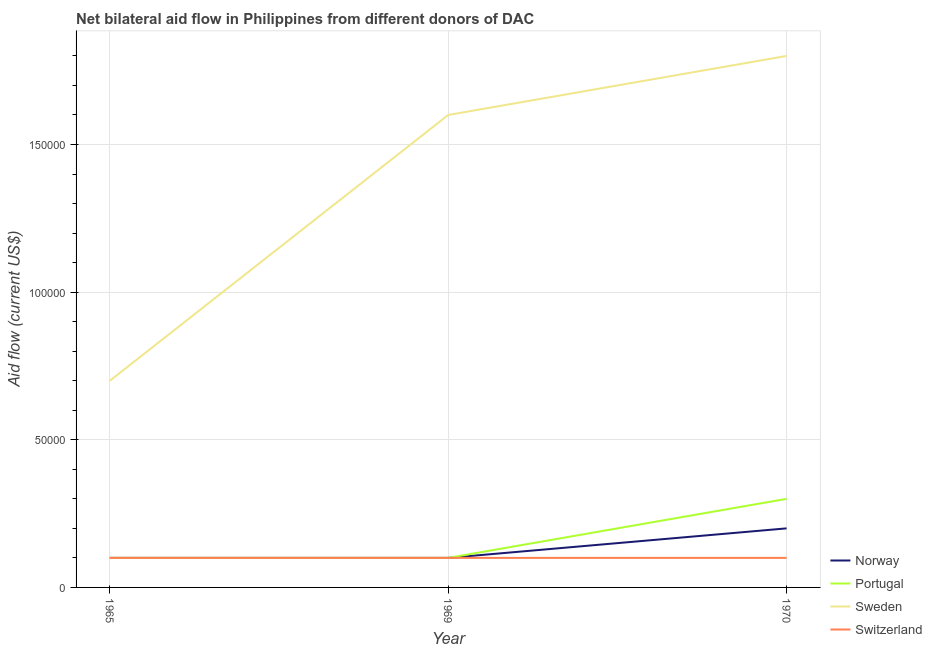How many different coloured lines are there?
Keep it short and to the point. 4. Does the line corresponding to amount of aid given by sweden intersect with the line corresponding to amount of aid given by portugal?
Provide a succinct answer. No. Is the number of lines equal to the number of legend labels?
Your response must be concise. Yes. What is the amount of aid given by switzerland in 1965?
Offer a terse response. 10000. Across all years, what is the maximum amount of aid given by sweden?
Provide a succinct answer. 1.80e+05. Across all years, what is the minimum amount of aid given by norway?
Offer a terse response. 10000. In which year was the amount of aid given by portugal maximum?
Your response must be concise. 1970. In which year was the amount of aid given by sweden minimum?
Provide a short and direct response. 1965. What is the total amount of aid given by norway in the graph?
Offer a very short reply. 4.00e+04. What is the difference between the amount of aid given by portugal in 1965 and that in 1970?
Provide a short and direct response. -2.00e+04. What is the difference between the amount of aid given by portugal in 1969 and the amount of aid given by switzerland in 1970?
Ensure brevity in your answer.  0. What is the average amount of aid given by switzerland per year?
Offer a terse response. 10000. In the year 1969, what is the difference between the amount of aid given by sweden and amount of aid given by switzerland?
Give a very brief answer. 1.50e+05. In how many years, is the amount of aid given by sweden greater than 10000 US$?
Make the answer very short. 3. What is the ratio of the amount of aid given by norway in 1965 to that in 1970?
Keep it short and to the point. 0.5. Is the difference between the amount of aid given by norway in 1969 and 1970 greater than the difference between the amount of aid given by portugal in 1969 and 1970?
Provide a succinct answer. Yes. What is the difference between the highest and the second highest amount of aid given by norway?
Your response must be concise. 10000. What is the difference between the highest and the lowest amount of aid given by norway?
Keep it short and to the point. 10000. Is it the case that in every year, the sum of the amount of aid given by norway and amount of aid given by portugal is greater than the amount of aid given by sweden?
Give a very brief answer. No. Is the amount of aid given by sweden strictly less than the amount of aid given by portugal over the years?
Keep it short and to the point. No. How many lines are there?
Give a very brief answer. 4. What is the difference between two consecutive major ticks on the Y-axis?
Keep it short and to the point. 5.00e+04. Are the values on the major ticks of Y-axis written in scientific E-notation?
Your response must be concise. No. Does the graph contain any zero values?
Your answer should be very brief. No. Does the graph contain grids?
Make the answer very short. Yes. How many legend labels are there?
Offer a terse response. 4. What is the title of the graph?
Ensure brevity in your answer.  Net bilateral aid flow in Philippines from different donors of DAC. What is the label or title of the X-axis?
Your response must be concise. Year. What is the label or title of the Y-axis?
Provide a short and direct response. Aid flow (current US$). What is the Aid flow (current US$) of Norway in 1965?
Provide a short and direct response. 10000. What is the Aid flow (current US$) of Sweden in 1969?
Your answer should be very brief. 1.60e+05. What is the Aid flow (current US$) of Norway in 1970?
Ensure brevity in your answer.  2.00e+04. What is the Aid flow (current US$) in Sweden in 1970?
Your answer should be compact. 1.80e+05. What is the Aid flow (current US$) of Switzerland in 1970?
Give a very brief answer. 10000. Across all years, what is the maximum Aid flow (current US$) of Norway?
Offer a terse response. 2.00e+04. Across all years, what is the maximum Aid flow (current US$) of Sweden?
Offer a very short reply. 1.80e+05. Across all years, what is the maximum Aid flow (current US$) of Switzerland?
Keep it short and to the point. 10000. Across all years, what is the minimum Aid flow (current US$) of Norway?
Your answer should be compact. 10000. Across all years, what is the minimum Aid flow (current US$) of Portugal?
Offer a very short reply. 10000. Across all years, what is the minimum Aid flow (current US$) in Sweden?
Make the answer very short. 7.00e+04. Across all years, what is the minimum Aid flow (current US$) in Switzerland?
Ensure brevity in your answer.  10000. What is the total Aid flow (current US$) in Norway in the graph?
Your answer should be compact. 4.00e+04. What is the total Aid flow (current US$) in Sweden in the graph?
Provide a short and direct response. 4.10e+05. What is the total Aid flow (current US$) in Switzerland in the graph?
Keep it short and to the point. 3.00e+04. What is the difference between the Aid flow (current US$) of Sweden in 1965 and that in 1969?
Make the answer very short. -9.00e+04. What is the difference between the Aid flow (current US$) in Switzerland in 1965 and that in 1969?
Ensure brevity in your answer.  0. What is the difference between the Aid flow (current US$) in Portugal in 1965 and that in 1970?
Provide a succinct answer. -2.00e+04. What is the difference between the Aid flow (current US$) in Switzerland in 1965 and that in 1970?
Make the answer very short. 0. What is the difference between the Aid flow (current US$) in Portugal in 1969 and that in 1970?
Your answer should be very brief. -2.00e+04. What is the difference between the Aid flow (current US$) in Sweden in 1969 and that in 1970?
Offer a very short reply. -2.00e+04. What is the difference between the Aid flow (current US$) of Switzerland in 1969 and that in 1970?
Give a very brief answer. 0. What is the difference between the Aid flow (current US$) of Norway in 1965 and the Aid flow (current US$) of Portugal in 1969?
Your answer should be compact. 0. What is the difference between the Aid flow (current US$) of Norway in 1965 and the Aid flow (current US$) of Switzerland in 1969?
Your response must be concise. 0. What is the difference between the Aid flow (current US$) in Portugal in 1965 and the Aid flow (current US$) in Sweden in 1969?
Your answer should be compact. -1.50e+05. What is the difference between the Aid flow (current US$) in Portugal in 1965 and the Aid flow (current US$) in Switzerland in 1969?
Make the answer very short. 0. What is the difference between the Aid flow (current US$) in Sweden in 1965 and the Aid flow (current US$) in Switzerland in 1969?
Offer a terse response. 6.00e+04. What is the difference between the Aid flow (current US$) of Norway in 1965 and the Aid flow (current US$) of Switzerland in 1970?
Your answer should be very brief. 0. What is the difference between the Aid flow (current US$) in Portugal in 1965 and the Aid flow (current US$) in Sweden in 1970?
Provide a succinct answer. -1.70e+05. What is the difference between the Aid flow (current US$) of Sweden in 1965 and the Aid flow (current US$) of Switzerland in 1970?
Offer a very short reply. 6.00e+04. What is the difference between the Aid flow (current US$) in Portugal in 1969 and the Aid flow (current US$) in Switzerland in 1970?
Offer a very short reply. 0. What is the average Aid flow (current US$) in Norway per year?
Keep it short and to the point. 1.33e+04. What is the average Aid flow (current US$) in Portugal per year?
Your response must be concise. 1.67e+04. What is the average Aid flow (current US$) in Sweden per year?
Your answer should be compact. 1.37e+05. In the year 1965, what is the difference between the Aid flow (current US$) in Norway and Aid flow (current US$) in Portugal?
Offer a very short reply. 0. In the year 1965, what is the difference between the Aid flow (current US$) in Norway and Aid flow (current US$) in Switzerland?
Provide a succinct answer. 0. In the year 1965, what is the difference between the Aid flow (current US$) of Portugal and Aid flow (current US$) of Sweden?
Your answer should be compact. -6.00e+04. In the year 1965, what is the difference between the Aid flow (current US$) of Portugal and Aid flow (current US$) of Switzerland?
Ensure brevity in your answer.  0. In the year 1969, what is the difference between the Aid flow (current US$) in Norway and Aid flow (current US$) in Sweden?
Offer a terse response. -1.50e+05. In the year 1969, what is the difference between the Aid flow (current US$) in Portugal and Aid flow (current US$) in Sweden?
Your answer should be compact. -1.50e+05. In the year 1969, what is the difference between the Aid flow (current US$) in Sweden and Aid flow (current US$) in Switzerland?
Make the answer very short. 1.50e+05. In the year 1970, what is the difference between the Aid flow (current US$) of Norway and Aid flow (current US$) of Sweden?
Provide a short and direct response. -1.60e+05. In the year 1970, what is the difference between the Aid flow (current US$) of Portugal and Aid flow (current US$) of Sweden?
Offer a terse response. -1.50e+05. In the year 1970, what is the difference between the Aid flow (current US$) of Portugal and Aid flow (current US$) of Switzerland?
Keep it short and to the point. 2.00e+04. In the year 1970, what is the difference between the Aid flow (current US$) of Sweden and Aid flow (current US$) of Switzerland?
Offer a very short reply. 1.70e+05. What is the ratio of the Aid flow (current US$) of Norway in 1965 to that in 1969?
Keep it short and to the point. 1. What is the ratio of the Aid flow (current US$) of Sweden in 1965 to that in 1969?
Keep it short and to the point. 0.44. What is the ratio of the Aid flow (current US$) of Switzerland in 1965 to that in 1969?
Keep it short and to the point. 1. What is the ratio of the Aid flow (current US$) in Sweden in 1965 to that in 1970?
Your answer should be compact. 0.39. What is the ratio of the Aid flow (current US$) of Norway in 1969 to that in 1970?
Provide a short and direct response. 0.5. What is the ratio of the Aid flow (current US$) in Portugal in 1969 to that in 1970?
Provide a short and direct response. 0.33. What is the difference between the highest and the second highest Aid flow (current US$) in Portugal?
Your answer should be compact. 2.00e+04. What is the difference between the highest and the second highest Aid flow (current US$) of Sweden?
Offer a very short reply. 2.00e+04. What is the difference between the highest and the second highest Aid flow (current US$) in Switzerland?
Ensure brevity in your answer.  0. 